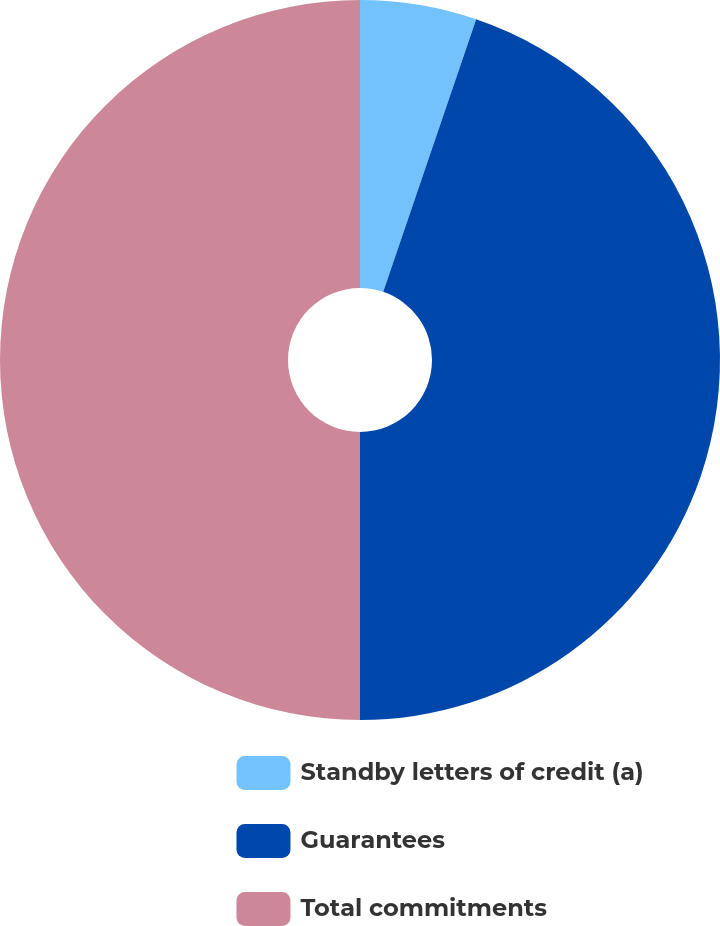<chart> <loc_0><loc_0><loc_500><loc_500><pie_chart><fcel>Standby letters of credit (a)<fcel>Guarantees<fcel>Total commitments<nl><fcel>5.23%<fcel>44.77%<fcel>50.0%<nl></chart> 